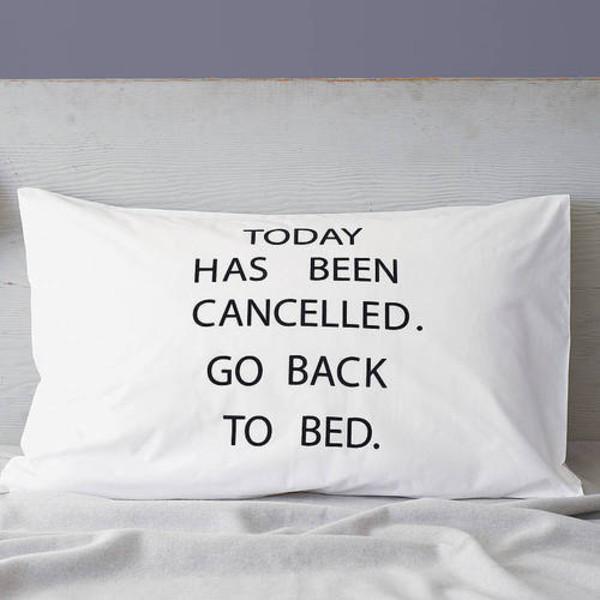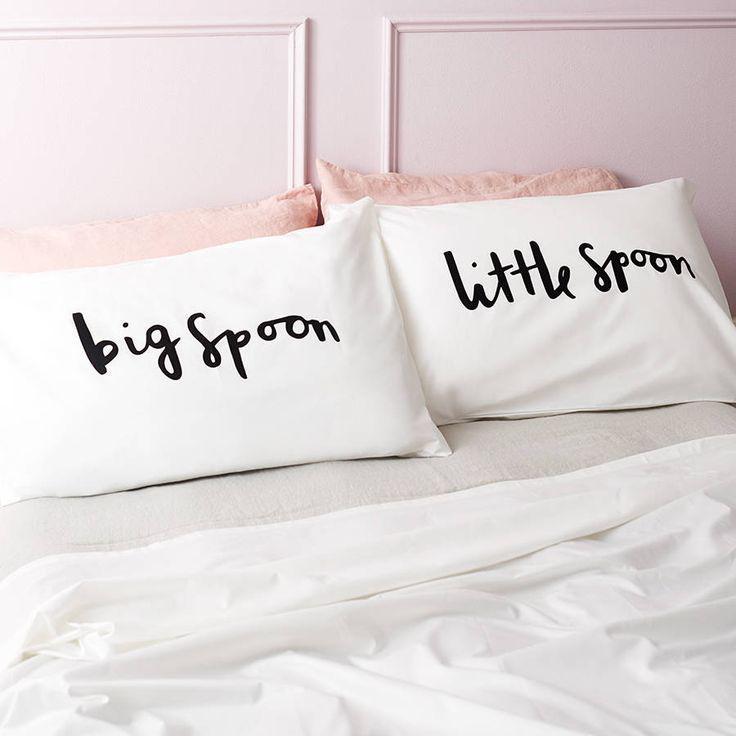The first image is the image on the left, the second image is the image on the right. Analyze the images presented: Is the assertion "The left image contains one rectangular pillow with black text on it, and the right image contains side-by-side pillows printed with black text." valid? Answer yes or no. Yes. The first image is the image on the left, the second image is the image on the right. Given the left and right images, does the statement "In one of the images there are 2 pillows resting against a white headboard." hold true? Answer yes or no. No. 